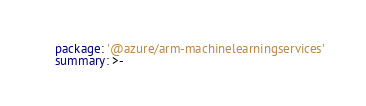<code> <loc_0><loc_0><loc_500><loc_500><_YAML_>    package: '@azure/arm-machinelearningservices'
    summary: >-</code> 